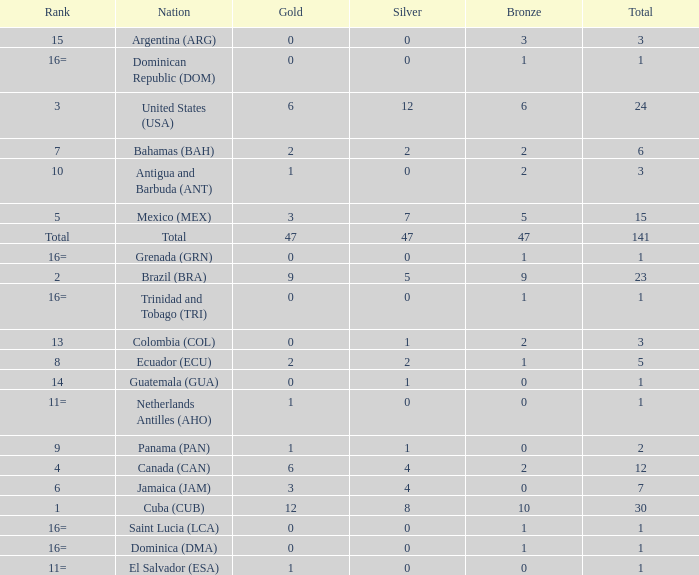What is the average silver with more than 0 gold, a Rank of 1, and a Total smaller than 30? None. 